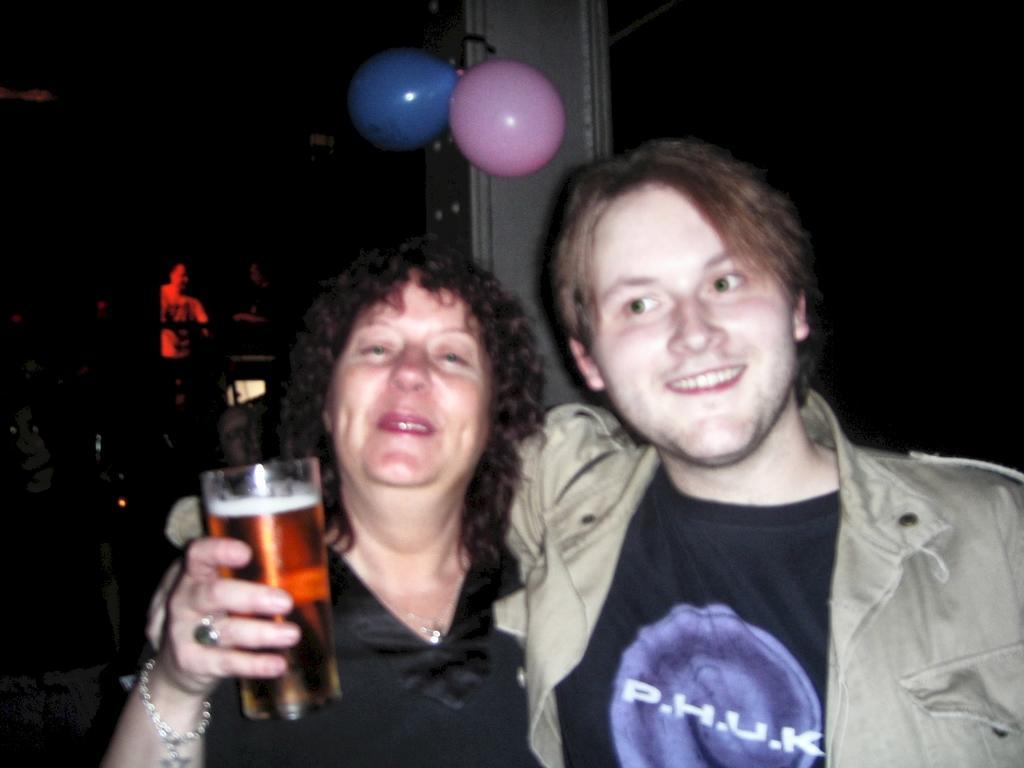Describe this image in one or two sentences. On the background we can see balloons and a person here. Here we can see a man and a women standing and they both hold a pretty smile on their faces. This woman is holding a drinking glass in her hand. 